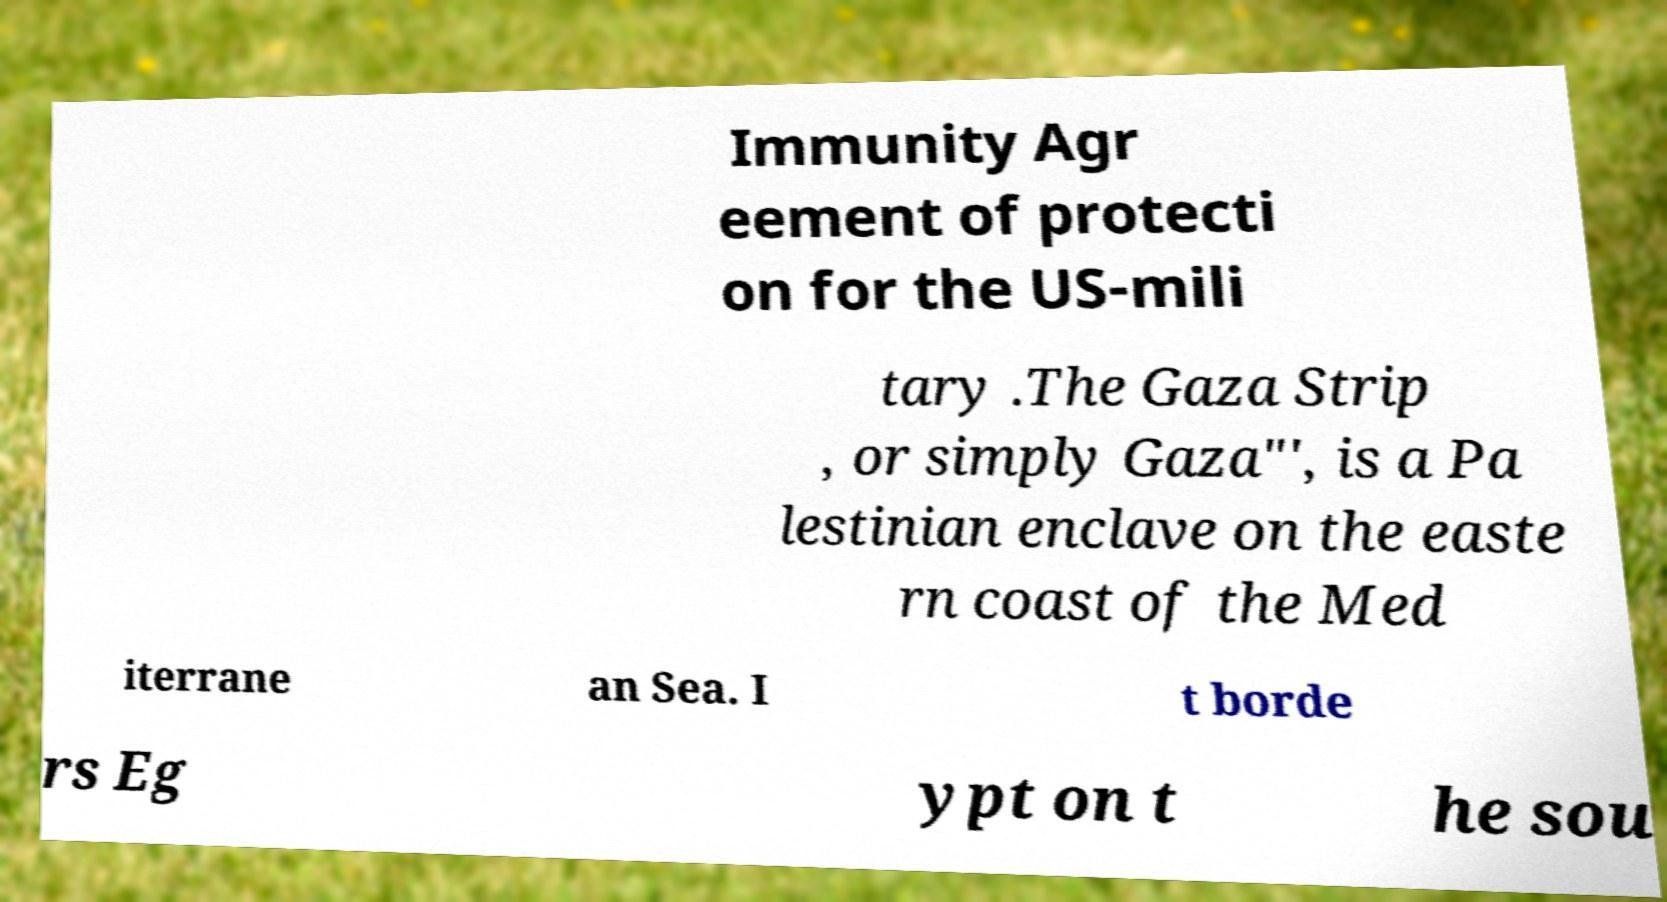Could you assist in decoding the text presented in this image and type it out clearly? Immunity Agr eement of protecti on for the US-mili tary .The Gaza Strip , or simply Gaza"', is a Pa lestinian enclave on the easte rn coast of the Med iterrane an Sea. I t borde rs Eg ypt on t he sou 